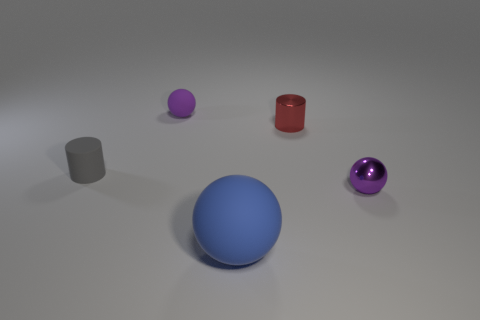Add 5 large things. How many objects exist? 10 Subtract all yellow spheres. Subtract all blue cubes. How many spheres are left? 3 Subtract all cylinders. How many objects are left? 3 Add 2 tiny cylinders. How many tiny cylinders exist? 4 Subtract 0 red cubes. How many objects are left? 5 Subtract all big cyan matte spheres. Subtract all blue rubber things. How many objects are left? 4 Add 5 tiny purple rubber balls. How many tiny purple rubber balls are left? 6 